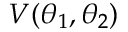<formula> <loc_0><loc_0><loc_500><loc_500>V ( \theta _ { 1 } , \theta _ { 2 } )</formula> 